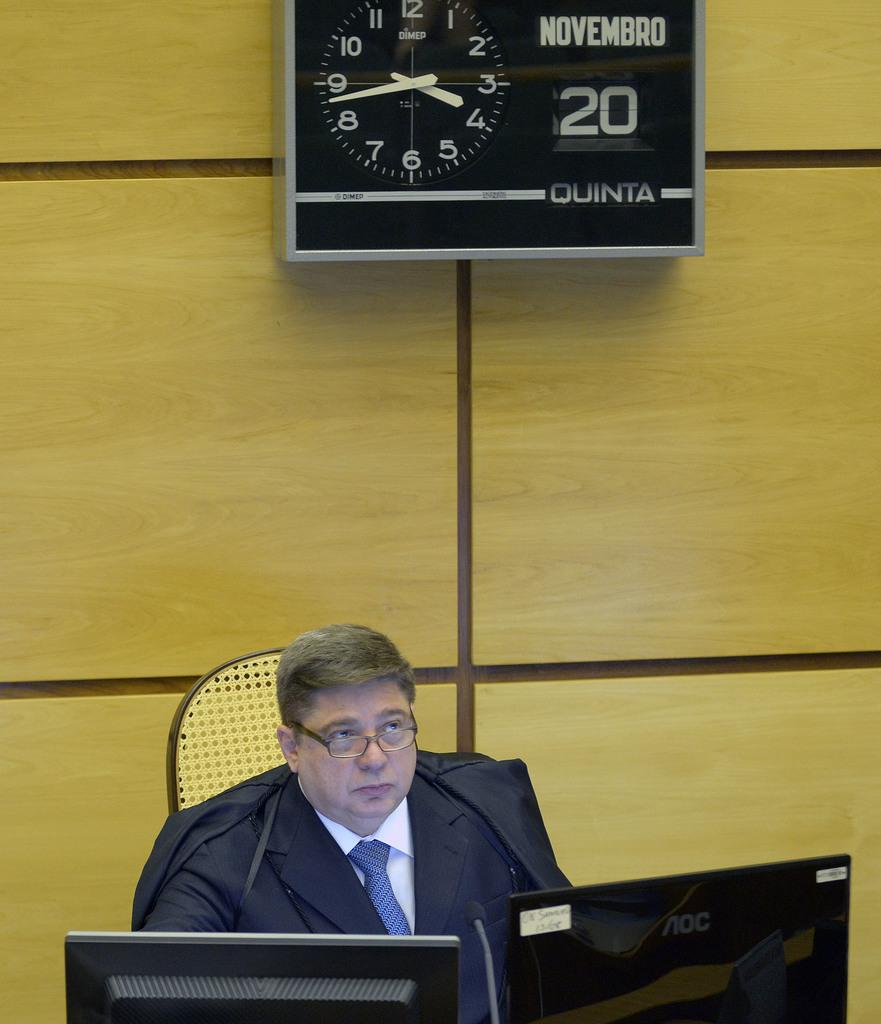<image>
Provide a brief description of the given image. Man sitting under a clock which says Novembro 20. 